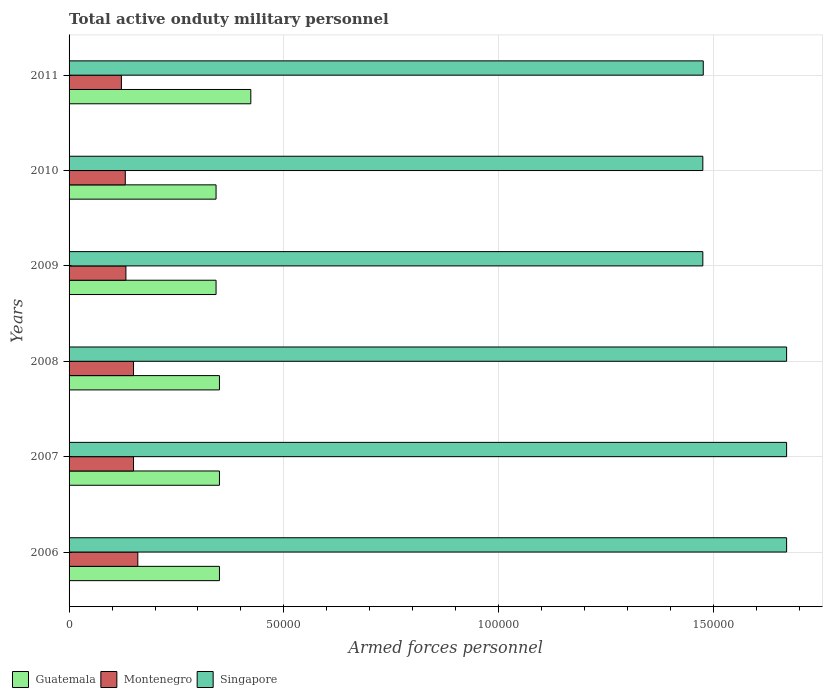How many different coloured bars are there?
Give a very brief answer. 3. How many groups of bars are there?
Your answer should be compact. 6. Are the number of bars on each tick of the Y-axis equal?
Your answer should be very brief. Yes. How many bars are there on the 1st tick from the top?
Ensure brevity in your answer.  3. What is the number of armed forces personnel in Singapore in 2008?
Your response must be concise. 1.67e+05. Across all years, what is the maximum number of armed forces personnel in Montenegro?
Keep it short and to the point. 1.60e+04. Across all years, what is the minimum number of armed forces personnel in Singapore?
Your response must be concise. 1.48e+05. In which year was the number of armed forces personnel in Montenegro minimum?
Provide a succinct answer. 2011. What is the total number of armed forces personnel in Guatemala in the graph?
Your response must be concise. 2.16e+05. What is the difference between the number of armed forces personnel in Singapore in 2006 and that in 2007?
Your answer should be very brief. 0. What is the difference between the number of armed forces personnel in Guatemala in 2006 and the number of armed forces personnel in Singapore in 2009?
Offer a very short reply. -1.12e+05. What is the average number of armed forces personnel in Singapore per year?
Provide a short and direct response. 1.57e+05. In the year 2007, what is the difference between the number of armed forces personnel in Montenegro and number of armed forces personnel in Singapore?
Provide a succinct answer. -1.52e+05. Is the number of armed forces personnel in Singapore in 2007 less than that in 2009?
Provide a succinct answer. No. Is the difference between the number of armed forces personnel in Montenegro in 2007 and 2009 greater than the difference between the number of armed forces personnel in Singapore in 2007 and 2009?
Ensure brevity in your answer.  No. What is the difference between the highest and the lowest number of armed forces personnel in Guatemala?
Ensure brevity in your answer.  8088. Is the sum of the number of armed forces personnel in Singapore in 2006 and 2007 greater than the maximum number of armed forces personnel in Guatemala across all years?
Keep it short and to the point. Yes. What does the 2nd bar from the top in 2010 represents?
Your answer should be compact. Montenegro. What does the 3rd bar from the bottom in 2008 represents?
Offer a terse response. Singapore. How many bars are there?
Ensure brevity in your answer.  18. Are the values on the major ticks of X-axis written in scientific E-notation?
Your answer should be very brief. No. Does the graph contain any zero values?
Give a very brief answer. No. How many legend labels are there?
Your response must be concise. 3. What is the title of the graph?
Offer a terse response. Total active onduty military personnel. Does "Denmark" appear as one of the legend labels in the graph?
Give a very brief answer. No. What is the label or title of the X-axis?
Your response must be concise. Armed forces personnel. What is the label or title of the Y-axis?
Keep it short and to the point. Years. What is the Armed forces personnel of Guatemala in 2006?
Offer a terse response. 3.50e+04. What is the Armed forces personnel of Montenegro in 2006?
Offer a terse response. 1.60e+04. What is the Armed forces personnel of Singapore in 2006?
Your answer should be compact. 1.67e+05. What is the Armed forces personnel of Guatemala in 2007?
Your answer should be compact. 3.50e+04. What is the Armed forces personnel of Montenegro in 2007?
Keep it short and to the point. 1.50e+04. What is the Armed forces personnel of Singapore in 2007?
Your answer should be very brief. 1.67e+05. What is the Armed forces personnel of Guatemala in 2008?
Ensure brevity in your answer.  3.50e+04. What is the Armed forces personnel of Montenegro in 2008?
Your answer should be very brief. 1.50e+04. What is the Armed forces personnel in Singapore in 2008?
Offer a very short reply. 1.67e+05. What is the Armed forces personnel in Guatemala in 2009?
Ensure brevity in your answer.  3.42e+04. What is the Armed forces personnel in Montenegro in 2009?
Give a very brief answer. 1.32e+04. What is the Armed forces personnel of Singapore in 2009?
Make the answer very short. 1.48e+05. What is the Armed forces personnel in Guatemala in 2010?
Your answer should be very brief. 3.42e+04. What is the Armed forces personnel in Montenegro in 2010?
Offer a very short reply. 1.31e+04. What is the Armed forces personnel in Singapore in 2010?
Your response must be concise. 1.48e+05. What is the Armed forces personnel in Guatemala in 2011?
Offer a terse response. 4.23e+04. What is the Armed forces personnel of Montenegro in 2011?
Your answer should be very brief. 1.22e+04. What is the Armed forces personnel in Singapore in 2011?
Give a very brief answer. 1.48e+05. Across all years, what is the maximum Armed forces personnel of Guatemala?
Give a very brief answer. 4.23e+04. Across all years, what is the maximum Armed forces personnel in Montenegro?
Give a very brief answer. 1.60e+04. Across all years, what is the maximum Armed forces personnel in Singapore?
Offer a terse response. 1.67e+05. Across all years, what is the minimum Armed forces personnel of Guatemala?
Your response must be concise. 3.42e+04. Across all years, what is the minimum Armed forces personnel in Montenegro?
Keep it short and to the point. 1.22e+04. Across all years, what is the minimum Armed forces personnel in Singapore?
Your answer should be very brief. 1.48e+05. What is the total Armed forces personnel of Guatemala in the graph?
Your answer should be very brief. 2.16e+05. What is the total Armed forces personnel in Montenegro in the graph?
Your response must be concise. 8.45e+04. What is the total Armed forces personnel in Singapore in the graph?
Your answer should be compact. 9.44e+05. What is the difference between the Armed forces personnel in Guatemala in 2006 and that in 2007?
Provide a short and direct response. 0. What is the difference between the Armed forces personnel of Singapore in 2006 and that in 2008?
Provide a short and direct response. 0. What is the difference between the Armed forces personnel in Guatemala in 2006 and that in 2009?
Your answer should be very brief. 788. What is the difference between the Armed forces personnel of Montenegro in 2006 and that in 2009?
Your response must be concise. 2773. What is the difference between the Armed forces personnel of Singapore in 2006 and that in 2009?
Offer a very short reply. 1.95e+04. What is the difference between the Armed forces personnel of Guatemala in 2006 and that in 2010?
Your answer should be very brief. 788. What is the difference between the Armed forces personnel in Montenegro in 2006 and that in 2010?
Your answer should be very brief. 2916. What is the difference between the Armed forces personnel in Singapore in 2006 and that in 2010?
Ensure brevity in your answer.  1.95e+04. What is the difference between the Armed forces personnel of Guatemala in 2006 and that in 2011?
Provide a short and direct response. -7300. What is the difference between the Armed forces personnel of Montenegro in 2006 and that in 2011?
Your answer should be very brief. 3820. What is the difference between the Armed forces personnel of Singapore in 2006 and that in 2011?
Your answer should be compact. 1.94e+04. What is the difference between the Armed forces personnel of Montenegro in 2007 and that in 2008?
Your answer should be very brief. 0. What is the difference between the Armed forces personnel of Singapore in 2007 and that in 2008?
Make the answer very short. 0. What is the difference between the Armed forces personnel of Guatemala in 2007 and that in 2009?
Provide a succinct answer. 788. What is the difference between the Armed forces personnel in Montenegro in 2007 and that in 2009?
Your answer should be very brief. 1773. What is the difference between the Armed forces personnel of Singapore in 2007 and that in 2009?
Offer a terse response. 1.95e+04. What is the difference between the Armed forces personnel in Guatemala in 2007 and that in 2010?
Ensure brevity in your answer.  788. What is the difference between the Armed forces personnel of Montenegro in 2007 and that in 2010?
Keep it short and to the point. 1916. What is the difference between the Armed forces personnel in Singapore in 2007 and that in 2010?
Give a very brief answer. 1.95e+04. What is the difference between the Armed forces personnel of Guatemala in 2007 and that in 2011?
Your answer should be very brief. -7300. What is the difference between the Armed forces personnel in Montenegro in 2007 and that in 2011?
Provide a succinct answer. 2820. What is the difference between the Armed forces personnel in Singapore in 2007 and that in 2011?
Your answer should be compact. 1.94e+04. What is the difference between the Armed forces personnel in Guatemala in 2008 and that in 2009?
Your response must be concise. 788. What is the difference between the Armed forces personnel in Montenegro in 2008 and that in 2009?
Keep it short and to the point. 1773. What is the difference between the Armed forces personnel of Singapore in 2008 and that in 2009?
Offer a very short reply. 1.95e+04. What is the difference between the Armed forces personnel in Guatemala in 2008 and that in 2010?
Your response must be concise. 788. What is the difference between the Armed forces personnel in Montenegro in 2008 and that in 2010?
Keep it short and to the point. 1916. What is the difference between the Armed forces personnel in Singapore in 2008 and that in 2010?
Offer a terse response. 1.95e+04. What is the difference between the Armed forces personnel of Guatemala in 2008 and that in 2011?
Provide a succinct answer. -7300. What is the difference between the Armed forces personnel in Montenegro in 2008 and that in 2011?
Offer a terse response. 2820. What is the difference between the Armed forces personnel of Singapore in 2008 and that in 2011?
Ensure brevity in your answer.  1.94e+04. What is the difference between the Armed forces personnel of Montenegro in 2009 and that in 2010?
Your answer should be compact. 143. What is the difference between the Armed forces personnel in Guatemala in 2009 and that in 2011?
Offer a very short reply. -8088. What is the difference between the Armed forces personnel of Montenegro in 2009 and that in 2011?
Keep it short and to the point. 1047. What is the difference between the Armed forces personnel in Singapore in 2009 and that in 2011?
Your answer should be compact. -100. What is the difference between the Armed forces personnel of Guatemala in 2010 and that in 2011?
Make the answer very short. -8088. What is the difference between the Armed forces personnel in Montenegro in 2010 and that in 2011?
Your answer should be very brief. 904. What is the difference between the Armed forces personnel of Singapore in 2010 and that in 2011?
Ensure brevity in your answer.  -100. What is the difference between the Armed forces personnel of Guatemala in 2006 and the Armed forces personnel of Singapore in 2007?
Give a very brief answer. -1.32e+05. What is the difference between the Armed forces personnel in Montenegro in 2006 and the Armed forces personnel in Singapore in 2007?
Keep it short and to the point. -1.51e+05. What is the difference between the Armed forces personnel in Guatemala in 2006 and the Armed forces personnel in Montenegro in 2008?
Offer a very short reply. 2.00e+04. What is the difference between the Armed forces personnel of Guatemala in 2006 and the Armed forces personnel of Singapore in 2008?
Your answer should be compact. -1.32e+05. What is the difference between the Armed forces personnel of Montenegro in 2006 and the Armed forces personnel of Singapore in 2008?
Offer a very short reply. -1.51e+05. What is the difference between the Armed forces personnel in Guatemala in 2006 and the Armed forces personnel in Montenegro in 2009?
Your response must be concise. 2.18e+04. What is the difference between the Armed forces personnel in Guatemala in 2006 and the Armed forces personnel in Singapore in 2009?
Ensure brevity in your answer.  -1.12e+05. What is the difference between the Armed forces personnel in Montenegro in 2006 and the Armed forces personnel in Singapore in 2009?
Keep it short and to the point. -1.32e+05. What is the difference between the Armed forces personnel in Guatemala in 2006 and the Armed forces personnel in Montenegro in 2010?
Your answer should be very brief. 2.19e+04. What is the difference between the Armed forces personnel in Guatemala in 2006 and the Armed forces personnel in Singapore in 2010?
Keep it short and to the point. -1.12e+05. What is the difference between the Armed forces personnel in Montenegro in 2006 and the Armed forces personnel in Singapore in 2010?
Make the answer very short. -1.32e+05. What is the difference between the Armed forces personnel in Guatemala in 2006 and the Armed forces personnel in Montenegro in 2011?
Make the answer very short. 2.28e+04. What is the difference between the Armed forces personnel of Guatemala in 2006 and the Armed forces personnel of Singapore in 2011?
Your answer should be compact. -1.13e+05. What is the difference between the Armed forces personnel in Montenegro in 2006 and the Armed forces personnel in Singapore in 2011?
Offer a very short reply. -1.32e+05. What is the difference between the Armed forces personnel of Guatemala in 2007 and the Armed forces personnel of Montenegro in 2008?
Offer a very short reply. 2.00e+04. What is the difference between the Armed forces personnel of Guatemala in 2007 and the Armed forces personnel of Singapore in 2008?
Offer a very short reply. -1.32e+05. What is the difference between the Armed forces personnel of Montenegro in 2007 and the Armed forces personnel of Singapore in 2008?
Your answer should be very brief. -1.52e+05. What is the difference between the Armed forces personnel in Guatemala in 2007 and the Armed forces personnel in Montenegro in 2009?
Make the answer very short. 2.18e+04. What is the difference between the Armed forces personnel of Guatemala in 2007 and the Armed forces personnel of Singapore in 2009?
Provide a succinct answer. -1.12e+05. What is the difference between the Armed forces personnel of Montenegro in 2007 and the Armed forces personnel of Singapore in 2009?
Ensure brevity in your answer.  -1.32e+05. What is the difference between the Armed forces personnel of Guatemala in 2007 and the Armed forces personnel of Montenegro in 2010?
Offer a very short reply. 2.19e+04. What is the difference between the Armed forces personnel in Guatemala in 2007 and the Armed forces personnel in Singapore in 2010?
Your answer should be very brief. -1.12e+05. What is the difference between the Armed forces personnel in Montenegro in 2007 and the Armed forces personnel in Singapore in 2010?
Ensure brevity in your answer.  -1.32e+05. What is the difference between the Armed forces personnel in Guatemala in 2007 and the Armed forces personnel in Montenegro in 2011?
Ensure brevity in your answer.  2.28e+04. What is the difference between the Armed forces personnel in Guatemala in 2007 and the Armed forces personnel in Singapore in 2011?
Offer a very short reply. -1.13e+05. What is the difference between the Armed forces personnel in Montenegro in 2007 and the Armed forces personnel in Singapore in 2011?
Your answer should be very brief. -1.33e+05. What is the difference between the Armed forces personnel in Guatemala in 2008 and the Armed forces personnel in Montenegro in 2009?
Provide a short and direct response. 2.18e+04. What is the difference between the Armed forces personnel in Guatemala in 2008 and the Armed forces personnel in Singapore in 2009?
Offer a terse response. -1.12e+05. What is the difference between the Armed forces personnel of Montenegro in 2008 and the Armed forces personnel of Singapore in 2009?
Offer a very short reply. -1.32e+05. What is the difference between the Armed forces personnel of Guatemala in 2008 and the Armed forces personnel of Montenegro in 2010?
Keep it short and to the point. 2.19e+04. What is the difference between the Armed forces personnel in Guatemala in 2008 and the Armed forces personnel in Singapore in 2010?
Make the answer very short. -1.12e+05. What is the difference between the Armed forces personnel in Montenegro in 2008 and the Armed forces personnel in Singapore in 2010?
Your response must be concise. -1.32e+05. What is the difference between the Armed forces personnel in Guatemala in 2008 and the Armed forces personnel in Montenegro in 2011?
Ensure brevity in your answer.  2.28e+04. What is the difference between the Armed forces personnel in Guatemala in 2008 and the Armed forces personnel in Singapore in 2011?
Keep it short and to the point. -1.13e+05. What is the difference between the Armed forces personnel of Montenegro in 2008 and the Armed forces personnel of Singapore in 2011?
Your answer should be very brief. -1.33e+05. What is the difference between the Armed forces personnel of Guatemala in 2009 and the Armed forces personnel of Montenegro in 2010?
Your answer should be very brief. 2.11e+04. What is the difference between the Armed forces personnel in Guatemala in 2009 and the Armed forces personnel in Singapore in 2010?
Keep it short and to the point. -1.13e+05. What is the difference between the Armed forces personnel of Montenegro in 2009 and the Armed forces personnel of Singapore in 2010?
Your response must be concise. -1.34e+05. What is the difference between the Armed forces personnel of Guatemala in 2009 and the Armed forces personnel of Montenegro in 2011?
Your answer should be compact. 2.20e+04. What is the difference between the Armed forces personnel in Guatemala in 2009 and the Armed forces personnel in Singapore in 2011?
Make the answer very short. -1.13e+05. What is the difference between the Armed forces personnel of Montenegro in 2009 and the Armed forces personnel of Singapore in 2011?
Your answer should be compact. -1.34e+05. What is the difference between the Armed forces personnel of Guatemala in 2010 and the Armed forces personnel of Montenegro in 2011?
Your answer should be very brief. 2.20e+04. What is the difference between the Armed forces personnel in Guatemala in 2010 and the Armed forces personnel in Singapore in 2011?
Provide a succinct answer. -1.13e+05. What is the difference between the Armed forces personnel in Montenegro in 2010 and the Armed forces personnel in Singapore in 2011?
Your response must be concise. -1.35e+05. What is the average Armed forces personnel of Guatemala per year?
Your answer should be very brief. 3.60e+04. What is the average Armed forces personnel of Montenegro per year?
Keep it short and to the point. 1.41e+04. What is the average Armed forces personnel of Singapore per year?
Offer a very short reply. 1.57e+05. In the year 2006, what is the difference between the Armed forces personnel of Guatemala and Armed forces personnel of Montenegro?
Your answer should be very brief. 1.90e+04. In the year 2006, what is the difference between the Armed forces personnel in Guatemala and Armed forces personnel in Singapore?
Provide a short and direct response. -1.32e+05. In the year 2006, what is the difference between the Armed forces personnel of Montenegro and Armed forces personnel of Singapore?
Offer a very short reply. -1.51e+05. In the year 2007, what is the difference between the Armed forces personnel in Guatemala and Armed forces personnel in Montenegro?
Provide a short and direct response. 2.00e+04. In the year 2007, what is the difference between the Armed forces personnel of Guatemala and Armed forces personnel of Singapore?
Your answer should be compact. -1.32e+05. In the year 2007, what is the difference between the Armed forces personnel in Montenegro and Armed forces personnel in Singapore?
Offer a terse response. -1.52e+05. In the year 2008, what is the difference between the Armed forces personnel in Guatemala and Armed forces personnel in Montenegro?
Keep it short and to the point. 2.00e+04. In the year 2008, what is the difference between the Armed forces personnel in Guatemala and Armed forces personnel in Singapore?
Make the answer very short. -1.32e+05. In the year 2008, what is the difference between the Armed forces personnel in Montenegro and Armed forces personnel in Singapore?
Your answer should be compact. -1.52e+05. In the year 2009, what is the difference between the Armed forces personnel in Guatemala and Armed forces personnel in Montenegro?
Keep it short and to the point. 2.10e+04. In the year 2009, what is the difference between the Armed forces personnel of Guatemala and Armed forces personnel of Singapore?
Your response must be concise. -1.13e+05. In the year 2009, what is the difference between the Armed forces personnel of Montenegro and Armed forces personnel of Singapore?
Your answer should be compact. -1.34e+05. In the year 2010, what is the difference between the Armed forces personnel of Guatemala and Armed forces personnel of Montenegro?
Offer a very short reply. 2.11e+04. In the year 2010, what is the difference between the Armed forces personnel in Guatemala and Armed forces personnel in Singapore?
Keep it short and to the point. -1.13e+05. In the year 2010, what is the difference between the Armed forces personnel in Montenegro and Armed forces personnel in Singapore?
Give a very brief answer. -1.34e+05. In the year 2011, what is the difference between the Armed forces personnel of Guatemala and Armed forces personnel of Montenegro?
Your answer should be very brief. 3.01e+04. In the year 2011, what is the difference between the Armed forces personnel in Guatemala and Armed forces personnel in Singapore?
Give a very brief answer. -1.05e+05. In the year 2011, what is the difference between the Armed forces personnel of Montenegro and Armed forces personnel of Singapore?
Offer a terse response. -1.35e+05. What is the ratio of the Armed forces personnel in Montenegro in 2006 to that in 2007?
Make the answer very short. 1.07. What is the ratio of the Armed forces personnel of Singapore in 2006 to that in 2007?
Keep it short and to the point. 1. What is the ratio of the Armed forces personnel of Guatemala in 2006 to that in 2008?
Make the answer very short. 1. What is the ratio of the Armed forces personnel of Montenegro in 2006 to that in 2008?
Ensure brevity in your answer.  1.07. What is the ratio of the Armed forces personnel in Guatemala in 2006 to that in 2009?
Ensure brevity in your answer.  1.02. What is the ratio of the Armed forces personnel of Montenegro in 2006 to that in 2009?
Give a very brief answer. 1.21. What is the ratio of the Armed forces personnel in Singapore in 2006 to that in 2009?
Provide a short and direct response. 1.13. What is the ratio of the Armed forces personnel of Guatemala in 2006 to that in 2010?
Provide a succinct answer. 1.02. What is the ratio of the Armed forces personnel in Montenegro in 2006 to that in 2010?
Your answer should be very brief. 1.22. What is the ratio of the Armed forces personnel of Singapore in 2006 to that in 2010?
Keep it short and to the point. 1.13. What is the ratio of the Armed forces personnel of Guatemala in 2006 to that in 2011?
Make the answer very short. 0.83. What is the ratio of the Armed forces personnel in Montenegro in 2006 to that in 2011?
Provide a short and direct response. 1.31. What is the ratio of the Armed forces personnel of Singapore in 2006 to that in 2011?
Provide a succinct answer. 1.13. What is the ratio of the Armed forces personnel in Guatemala in 2007 to that in 2008?
Your response must be concise. 1. What is the ratio of the Armed forces personnel of Montenegro in 2007 to that in 2009?
Provide a short and direct response. 1.13. What is the ratio of the Armed forces personnel in Singapore in 2007 to that in 2009?
Offer a terse response. 1.13. What is the ratio of the Armed forces personnel of Guatemala in 2007 to that in 2010?
Your answer should be very brief. 1.02. What is the ratio of the Armed forces personnel of Montenegro in 2007 to that in 2010?
Your response must be concise. 1.15. What is the ratio of the Armed forces personnel of Singapore in 2007 to that in 2010?
Offer a terse response. 1.13. What is the ratio of the Armed forces personnel of Guatemala in 2007 to that in 2011?
Provide a short and direct response. 0.83. What is the ratio of the Armed forces personnel in Montenegro in 2007 to that in 2011?
Make the answer very short. 1.23. What is the ratio of the Armed forces personnel in Singapore in 2007 to that in 2011?
Provide a short and direct response. 1.13. What is the ratio of the Armed forces personnel of Guatemala in 2008 to that in 2009?
Your answer should be very brief. 1.02. What is the ratio of the Armed forces personnel of Montenegro in 2008 to that in 2009?
Give a very brief answer. 1.13. What is the ratio of the Armed forces personnel of Singapore in 2008 to that in 2009?
Keep it short and to the point. 1.13. What is the ratio of the Armed forces personnel of Guatemala in 2008 to that in 2010?
Offer a very short reply. 1.02. What is the ratio of the Armed forces personnel in Montenegro in 2008 to that in 2010?
Give a very brief answer. 1.15. What is the ratio of the Armed forces personnel in Singapore in 2008 to that in 2010?
Ensure brevity in your answer.  1.13. What is the ratio of the Armed forces personnel in Guatemala in 2008 to that in 2011?
Give a very brief answer. 0.83. What is the ratio of the Armed forces personnel in Montenegro in 2008 to that in 2011?
Ensure brevity in your answer.  1.23. What is the ratio of the Armed forces personnel in Singapore in 2008 to that in 2011?
Offer a terse response. 1.13. What is the ratio of the Armed forces personnel in Montenegro in 2009 to that in 2010?
Ensure brevity in your answer.  1.01. What is the ratio of the Armed forces personnel of Singapore in 2009 to that in 2010?
Offer a terse response. 1. What is the ratio of the Armed forces personnel of Guatemala in 2009 to that in 2011?
Provide a succinct answer. 0.81. What is the ratio of the Armed forces personnel of Montenegro in 2009 to that in 2011?
Keep it short and to the point. 1.09. What is the ratio of the Armed forces personnel of Singapore in 2009 to that in 2011?
Offer a very short reply. 1. What is the ratio of the Armed forces personnel in Guatemala in 2010 to that in 2011?
Provide a succinct answer. 0.81. What is the ratio of the Armed forces personnel in Montenegro in 2010 to that in 2011?
Give a very brief answer. 1.07. What is the difference between the highest and the second highest Armed forces personnel of Guatemala?
Your response must be concise. 7300. What is the difference between the highest and the second highest Armed forces personnel of Singapore?
Your answer should be very brief. 0. What is the difference between the highest and the lowest Armed forces personnel of Guatemala?
Provide a succinct answer. 8088. What is the difference between the highest and the lowest Armed forces personnel of Montenegro?
Keep it short and to the point. 3820. What is the difference between the highest and the lowest Armed forces personnel in Singapore?
Provide a succinct answer. 1.95e+04. 